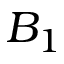Convert formula to latex. <formula><loc_0><loc_0><loc_500><loc_500>B _ { 1 }</formula> 